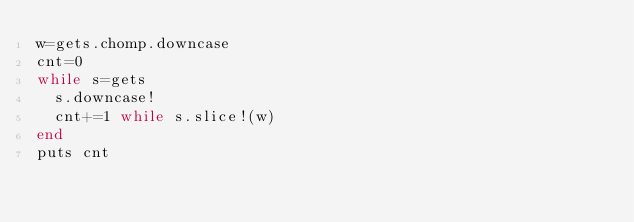<code> <loc_0><loc_0><loc_500><loc_500><_Ruby_>w=gets.chomp.downcase
cnt=0
while s=gets
  s.downcase!
  cnt+=1 while s.slice!(w)
end
puts cnt</code> 